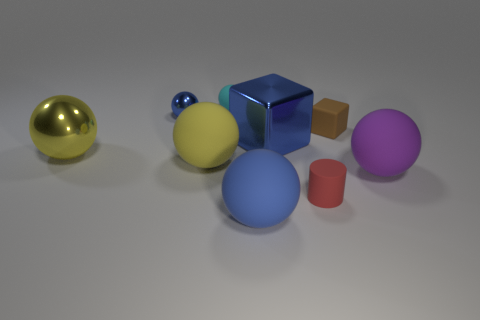Subtract all big yellow metal spheres. How many spheres are left? 5 Subtract all green blocks. How many blue balls are left? 2 Subtract 2 balls. How many balls are left? 4 Subtract all purple balls. How many balls are left? 5 Subtract all cyan balls. Subtract all cyan cylinders. How many balls are left? 5 Subtract all cubes. How many objects are left? 7 Subtract all cyan matte things. Subtract all cubes. How many objects are left? 6 Add 8 blue matte objects. How many blue matte objects are left? 9 Add 3 small rubber spheres. How many small rubber spheres exist? 4 Subtract 0 green cylinders. How many objects are left? 9 